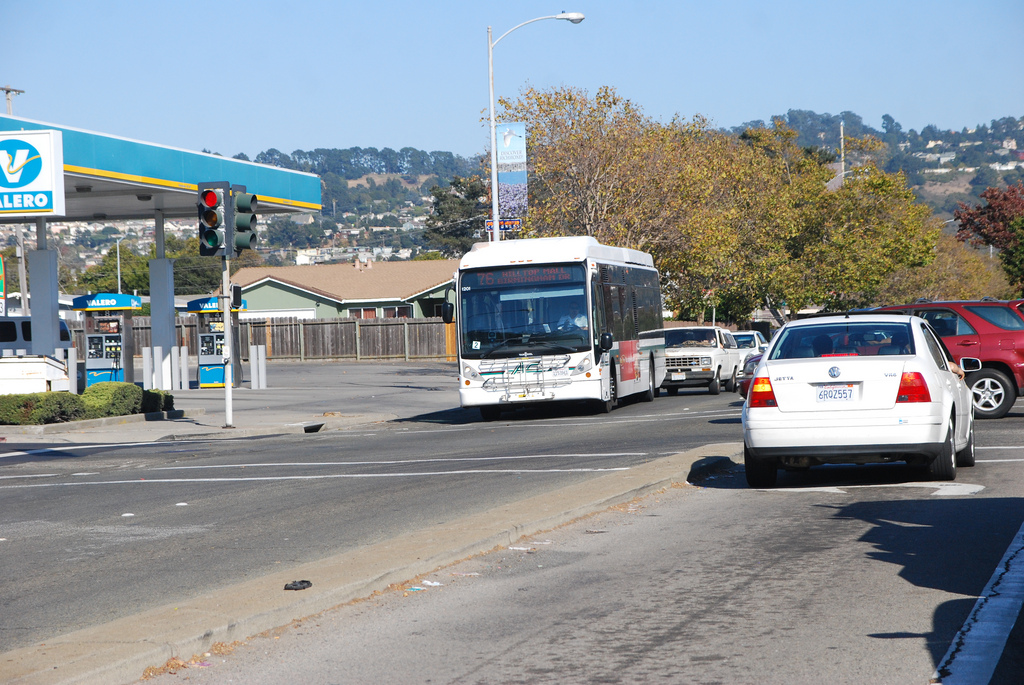What establishment can be seen in the background on the left? In the background on the left, there is a Valero gas station identifiable by its blue and white branding. 